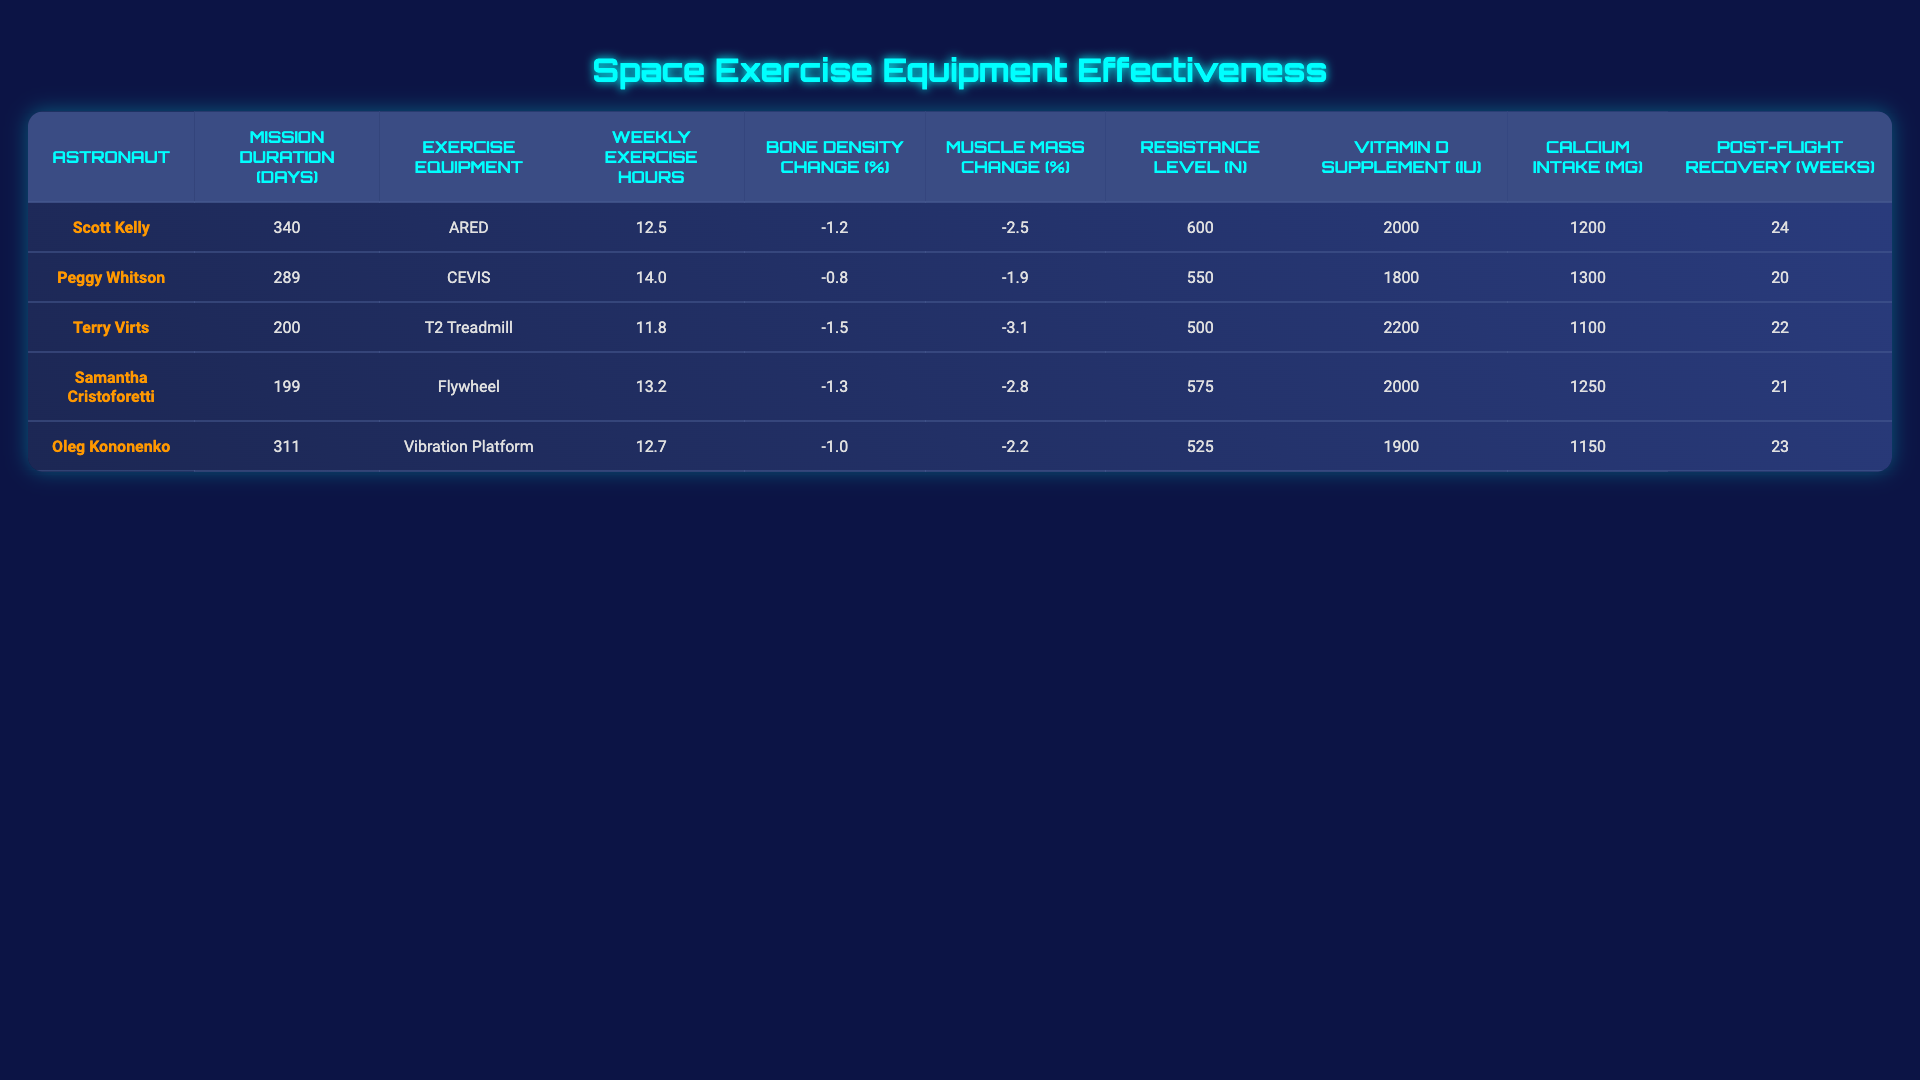What is the weekly exercise hour average among the astronauts? To find the average, we add the weekly exercise hours: (12.5 + 14.0 + 11.8 + 13.2 + 12.7) = 64.2. Then divide by the number of astronauts (5): 64.2 / 5 = 12.84.
Answer: 12.84 hours Which astronaut used the ARED exercise equipment? The table lists Scott Kelly as the astronaut who used the ARED exercise equipment.
Answer: Scott Kelly What was the bone density change for the astronaut who exercised the longest? The astronaut with the longest mission duration is Scott Kelly (340 days) who had a bone density change of -1.2%.
Answer: -1.2% Is there a relationship between resistance level and muscle mass change? To explore this, we examine the resistance levels and the corresponding muscle mass changes. Lower resistance levels like 500N correspond to a change of -3.1%, while higher levels like 600N correspond to -2.5%. This suggests that higher resistance might be associated with less muscle mass loss.
Answer: Yes, higher resistance may correlate with less muscle mass loss What is the difference in calcium intake between the astronaut with the highest and the lowest intake? The astronaut with the highest calcium intake is Peggy Whitson (1300 mg) and the lowest is Terry Virts (1100 mg). The difference is 1300 - 1100 = 200 mg.
Answer: 200 mg Who had the longest post-flight recovery, and what exercise equipment did they use? Oleg Kononenko had the longest post-flight recovery period of 24 weeks and he used the Vibration Platform for exercise.
Answer: Oleg Kononenko used the Vibration Platform What percentage change in muscle mass did Samantha Cristoforetti experience? Samantha Cristoforetti's muscle mass change is listed as -2.8%.
Answer: -2.8% Can we determine if calcium intake impacts bone density change based on this data? To analyze this, we look at astronauts with varying calcium intakes and their corresponding bone density changes. There isn’t a clear trend between higher or lower calcium intake and bone density change, indicating we cannot definitively conclude an impact based on this data alone.
Answer: No, no clear impact can be determined Which astronaut experienced the most significant muscle mass decline and what was their exercise equipment? Terry Virts experienced the most significant muscle mass decline of -3.1% and used the T2 Treadmill for exercise.
Answer: Terry Virts used the T2 Treadmill What is the average bone density change across all astronauts? The average bone density change is calculated by summing the changes: (-1.2 - 0.8 - 1.5 - 1.3 - 1.0) = -5.8, then dividing by the number of astronauts (5): -5.8 / 5 = -1.16%.
Answer: -1.16% Did any astronaut take more than 2000 IU of Vitamin D supplementation? Yes, both Terry Virts and Samantha Cristoforetti took 2200 IU of Vitamin D supplementation.
Answer: Yes, two astronauts did 